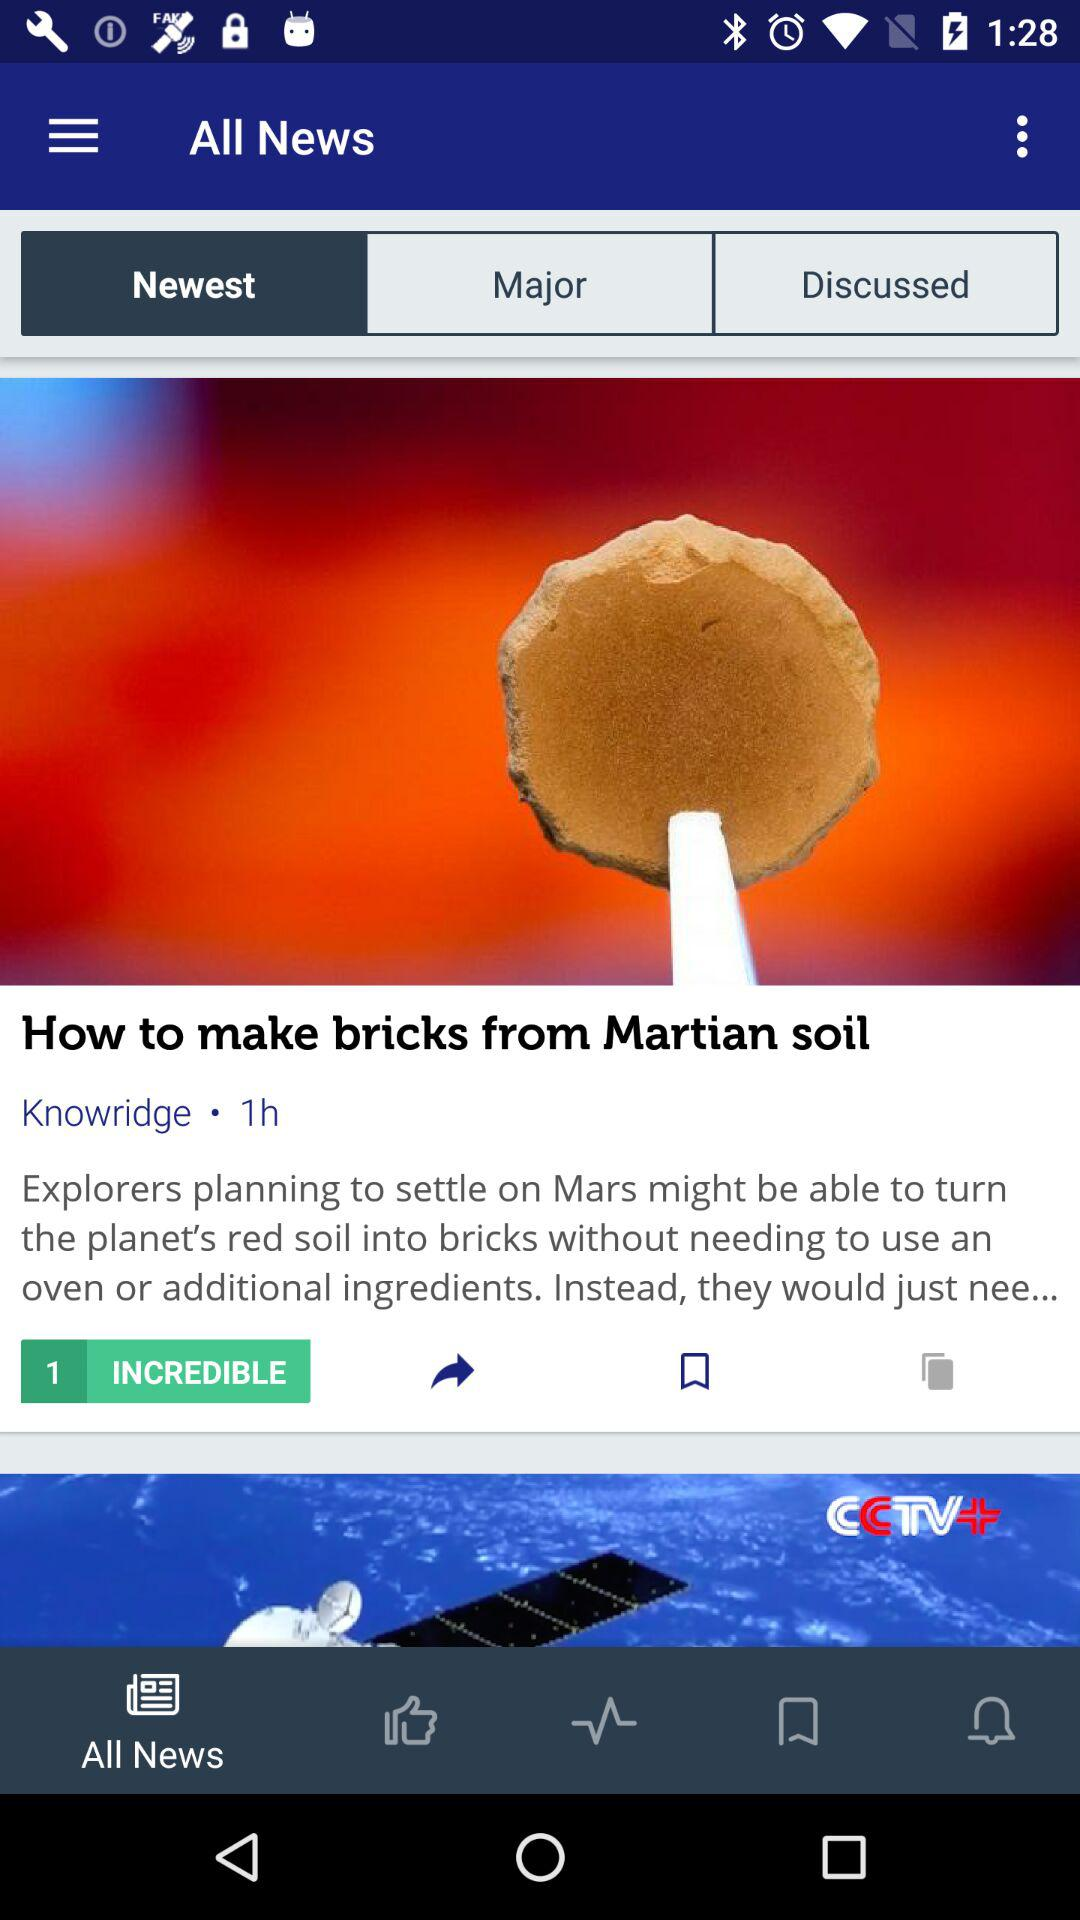Which tab is selected in "All News"? The selected tab is "Newest". 